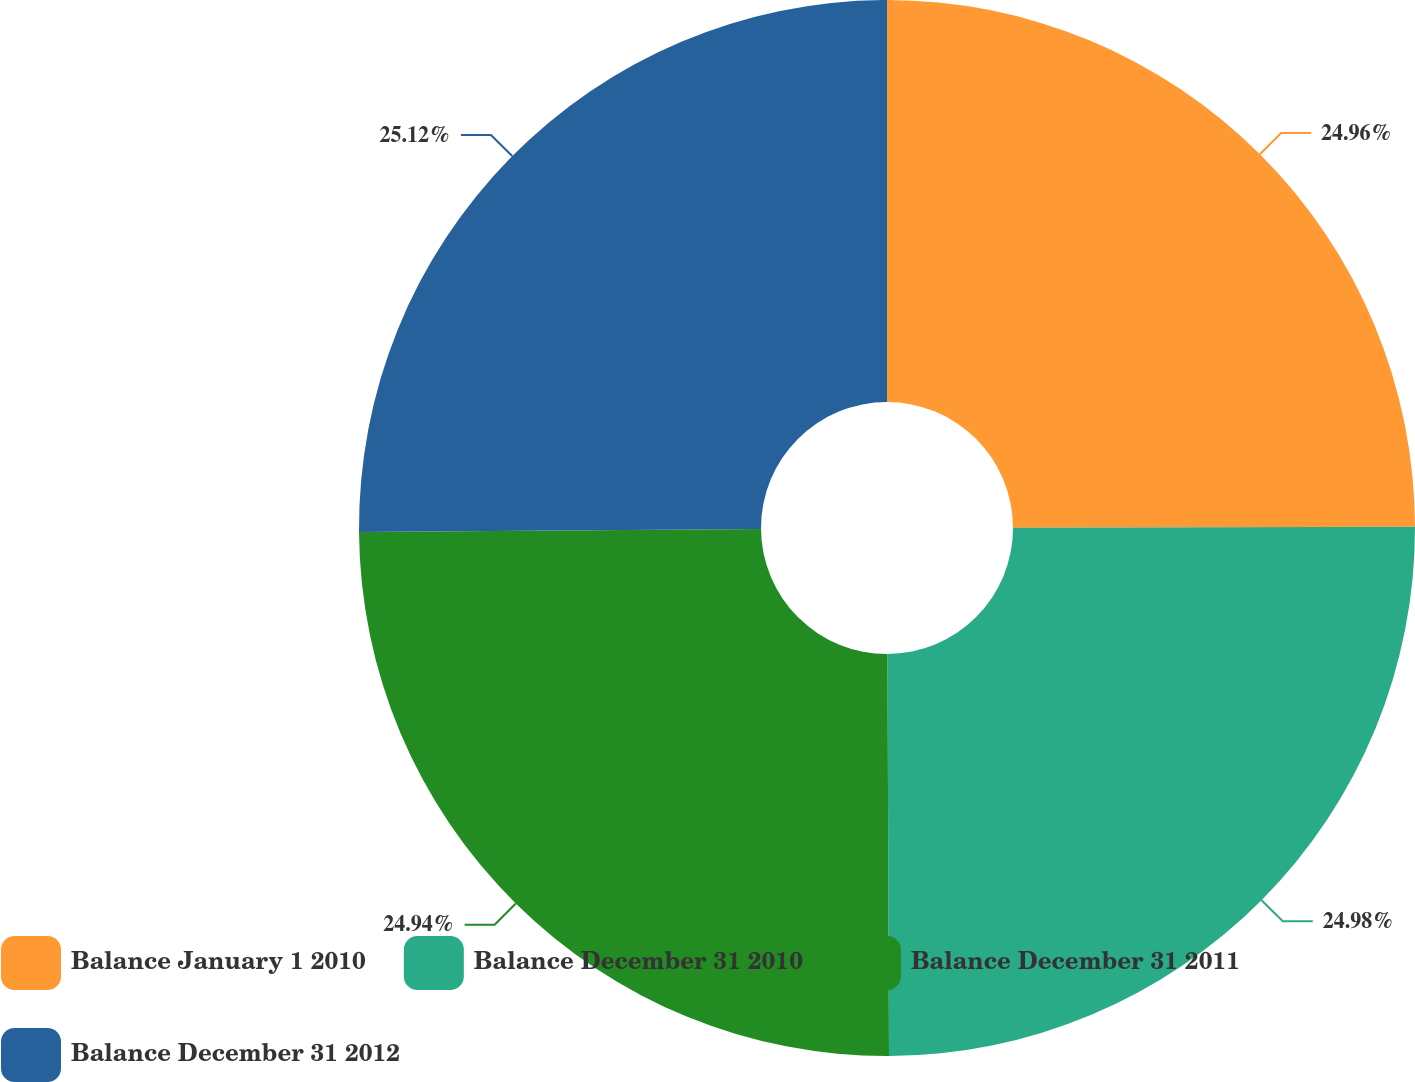Convert chart to OTSL. <chart><loc_0><loc_0><loc_500><loc_500><pie_chart><fcel>Balance January 1 2010<fcel>Balance December 31 2010<fcel>Balance December 31 2011<fcel>Balance December 31 2012<nl><fcel>24.96%<fcel>24.98%<fcel>24.94%<fcel>25.12%<nl></chart> 